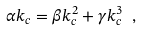<formula> <loc_0><loc_0><loc_500><loc_500>\alpha k _ { c } = \beta k _ { c } ^ { 2 } + \gamma k _ { c } ^ { 3 } \ ,</formula> 